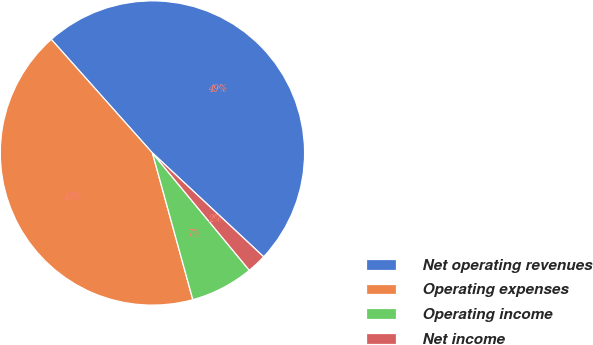Convert chart. <chart><loc_0><loc_0><loc_500><loc_500><pie_chart><fcel>Net operating revenues<fcel>Operating expenses<fcel>Operating income<fcel>Net income<nl><fcel>48.53%<fcel>42.7%<fcel>6.71%<fcel>2.06%<nl></chart> 